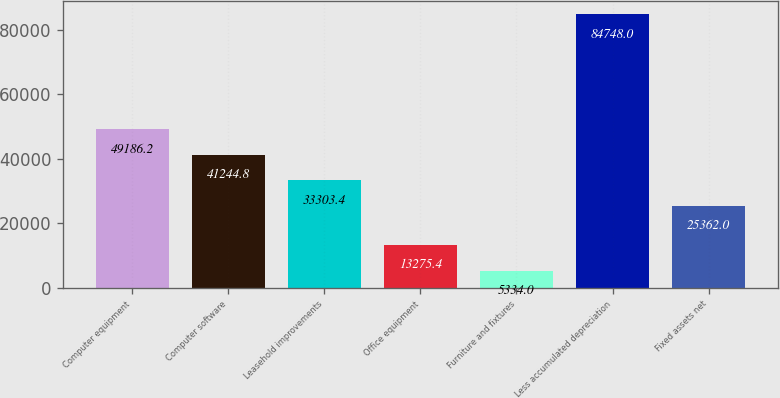Convert chart to OTSL. <chart><loc_0><loc_0><loc_500><loc_500><bar_chart><fcel>Computer equipment<fcel>Computer software<fcel>Leasehold improvements<fcel>Office equipment<fcel>Furniture and fixtures<fcel>Less accumulated depreciation<fcel>Fixed assets net<nl><fcel>49186.2<fcel>41244.8<fcel>33303.4<fcel>13275.4<fcel>5334<fcel>84748<fcel>25362<nl></chart> 